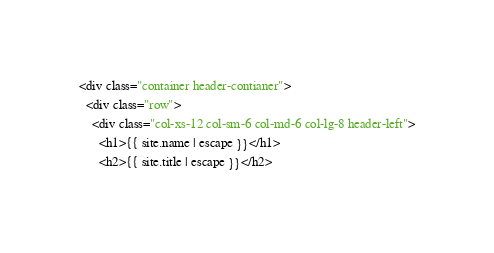Convert code to text. <code><loc_0><loc_0><loc_500><loc_500><_HTML_><div class="container header-contianer">
  <div class="row">
    <div class="col-xs-12 col-sm-6 col-md-6 col-lg-8 header-left">
      <h1>{{ site.name | escape }}</h1>
      <h2>{{ site.title | escape }}</h2></code> 